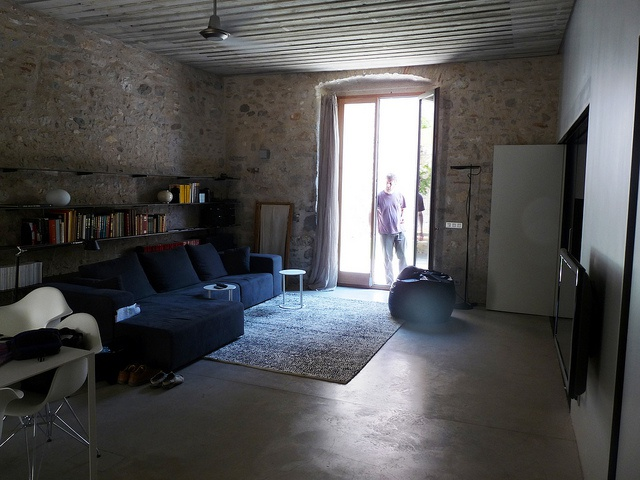Describe the objects in this image and their specific colors. I can see couch in black, navy, darkblue, and blue tones, chair in black and gray tones, tv in black, gray, and darkgray tones, dining table in black tones, and chair in black, darkgray, and gray tones in this image. 